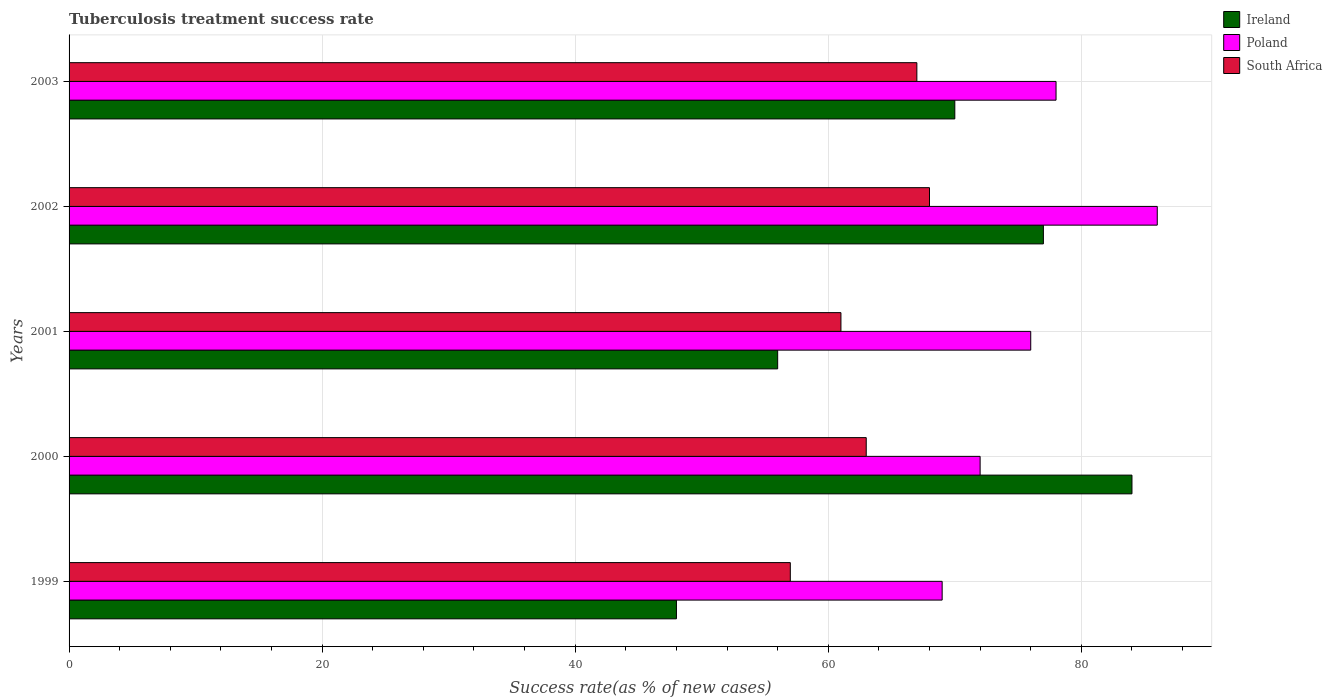How many groups of bars are there?
Keep it short and to the point. 5. Are the number of bars on each tick of the Y-axis equal?
Provide a short and direct response. Yes. What is the label of the 4th group of bars from the top?
Your response must be concise. 2000. In how many cases, is the number of bars for a given year not equal to the number of legend labels?
Ensure brevity in your answer.  0. What is the tuberculosis treatment success rate in Poland in 2001?
Your response must be concise. 76. Across all years, what is the maximum tuberculosis treatment success rate in South Africa?
Provide a succinct answer. 68. Across all years, what is the minimum tuberculosis treatment success rate in Ireland?
Provide a short and direct response. 48. In which year was the tuberculosis treatment success rate in South Africa maximum?
Your response must be concise. 2002. In which year was the tuberculosis treatment success rate in South Africa minimum?
Keep it short and to the point. 1999. What is the total tuberculosis treatment success rate in South Africa in the graph?
Ensure brevity in your answer.  316. What is the difference between the tuberculosis treatment success rate in Ireland in 2002 and that in 2003?
Offer a very short reply. 7. What is the difference between the tuberculosis treatment success rate in Ireland in 2000 and the tuberculosis treatment success rate in South Africa in 1999?
Your answer should be compact. 27. What is the average tuberculosis treatment success rate in Poland per year?
Provide a short and direct response. 76.2. What is the ratio of the tuberculosis treatment success rate in Ireland in 2001 to that in 2002?
Keep it short and to the point. 0.73. Is the tuberculosis treatment success rate in South Africa in 2000 less than that in 2002?
Give a very brief answer. Yes. Is the difference between the tuberculosis treatment success rate in Poland in 2002 and 2003 greater than the difference between the tuberculosis treatment success rate in Ireland in 2002 and 2003?
Offer a terse response. Yes. What is the difference between the highest and the second highest tuberculosis treatment success rate in Ireland?
Make the answer very short. 7. What is the difference between the highest and the lowest tuberculosis treatment success rate in South Africa?
Your answer should be compact. 11. In how many years, is the tuberculosis treatment success rate in Poland greater than the average tuberculosis treatment success rate in Poland taken over all years?
Your answer should be compact. 2. What does the 3rd bar from the top in 2003 represents?
Provide a succinct answer. Ireland. What does the 2nd bar from the bottom in 1999 represents?
Provide a short and direct response. Poland. Is it the case that in every year, the sum of the tuberculosis treatment success rate in Ireland and tuberculosis treatment success rate in Poland is greater than the tuberculosis treatment success rate in South Africa?
Offer a very short reply. Yes. How many years are there in the graph?
Offer a very short reply. 5. What is the difference between two consecutive major ticks on the X-axis?
Give a very brief answer. 20. Does the graph contain any zero values?
Your answer should be compact. No. Does the graph contain grids?
Make the answer very short. Yes. Where does the legend appear in the graph?
Keep it short and to the point. Top right. How many legend labels are there?
Provide a succinct answer. 3. How are the legend labels stacked?
Keep it short and to the point. Vertical. What is the title of the graph?
Your answer should be compact. Tuberculosis treatment success rate. Does "Angola" appear as one of the legend labels in the graph?
Make the answer very short. No. What is the label or title of the X-axis?
Ensure brevity in your answer.  Success rate(as % of new cases). What is the label or title of the Y-axis?
Keep it short and to the point. Years. What is the Success rate(as % of new cases) of Ireland in 2000?
Your answer should be compact. 84. What is the Success rate(as % of new cases) in Poland in 2000?
Your answer should be very brief. 72. What is the Success rate(as % of new cases) of Ireland in 2001?
Provide a short and direct response. 56. What is the Success rate(as % of new cases) of South Africa in 2001?
Your answer should be compact. 61. What is the Success rate(as % of new cases) in Poland in 2002?
Provide a succinct answer. 86. What is the Success rate(as % of new cases) in South Africa in 2002?
Your response must be concise. 68. What is the Success rate(as % of new cases) in South Africa in 2003?
Your answer should be compact. 67. Across all years, what is the maximum Success rate(as % of new cases) of Poland?
Ensure brevity in your answer.  86. Across all years, what is the minimum Success rate(as % of new cases) in South Africa?
Ensure brevity in your answer.  57. What is the total Success rate(as % of new cases) of Ireland in the graph?
Provide a short and direct response. 335. What is the total Success rate(as % of new cases) in Poland in the graph?
Provide a succinct answer. 381. What is the total Success rate(as % of new cases) in South Africa in the graph?
Provide a short and direct response. 316. What is the difference between the Success rate(as % of new cases) of Ireland in 1999 and that in 2000?
Give a very brief answer. -36. What is the difference between the Success rate(as % of new cases) in Poland in 1999 and that in 2001?
Provide a short and direct response. -7. What is the difference between the Success rate(as % of new cases) of Ireland in 1999 and that in 2002?
Keep it short and to the point. -29. What is the difference between the Success rate(as % of new cases) in Poland in 1999 and that in 2002?
Your response must be concise. -17. What is the difference between the Success rate(as % of new cases) of Poland in 1999 and that in 2003?
Make the answer very short. -9. What is the difference between the Success rate(as % of new cases) of South Africa in 1999 and that in 2003?
Your response must be concise. -10. What is the difference between the Success rate(as % of new cases) in Ireland in 2000 and that in 2001?
Your answer should be compact. 28. What is the difference between the Success rate(as % of new cases) in Poland in 2000 and that in 2001?
Offer a terse response. -4. What is the difference between the Success rate(as % of new cases) of South Africa in 2000 and that in 2001?
Ensure brevity in your answer.  2. What is the difference between the Success rate(as % of new cases) in Poland in 2000 and that in 2002?
Provide a succinct answer. -14. What is the difference between the Success rate(as % of new cases) in South Africa in 2000 and that in 2002?
Offer a very short reply. -5. What is the difference between the Success rate(as % of new cases) in Ireland in 2001 and that in 2002?
Keep it short and to the point. -21. What is the difference between the Success rate(as % of new cases) in South Africa in 2001 and that in 2002?
Provide a succinct answer. -7. What is the difference between the Success rate(as % of new cases) of Ireland in 2001 and that in 2003?
Offer a terse response. -14. What is the difference between the Success rate(as % of new cases) of Poland in 2002 and that in 2003?
Make the answer very short. 8. What is the difference between the Success rate(as % of new cases) of South Africa in 2002 and that in 2003?
Ensure brevity in your answer.  1. What is the difference between the Success rate(as % of new cases) of Poland in 1999 and the Success rate(as % of new cases) of South Africa in 2000?
Your answer should be compact. 6. What is the difference between the Success rate(as % of new cases) of Ireland in 1999 and the Success rate(as % of new cases) of Poland in 2002?
Provide a short and direct response. -38. What is the difference between the Success rate(as % of new cases) of Ireland in 1999 and the Success rate(as % of new cases) of South Africa in 2002?
Offer a terse response. -20. What is the difference between the Success rate(as % of new cases) of Ireland in 1999 and the Success rate(as % of new cases) of Poland in 2003?
Your answer should be compact. -30. What is the difference between the Success rate(as % of new cases) of Ireland in 2000 and the Success rate(as % of new cases) of Poland in 2001?
Give a very brief answer. 8. What is the difference between the Success rate(as % of new cases) in Ireland in 2000 and the Success rate(as % of new cases) in South Africa in 2001?
Offer a terse response. 23. What is the difference between the Success rate(as % of new cases) of Ireland in 2000 and the Success rate(as % of new cases) of Poland in 2002?
Your response must be concise. -2. What is the difference between the Success rate(as % of new cases) of Ireland in 2000 and the Success rate(as % of new cases) of South Africa in 2002?
Keep it short and to the point. 16. What is the difference between the Success rate(as % of new cases) in Ireland in 2000 and the Success rate(as % of new cases) in Poland in 2003?
Provide a succinct answer. 6. What is the difference between the Success rate(as % of new cases) in Ireland in 2001 and the Success rate(as % of new cases) in South Africa in 2002?
Your response must be concise. -12. What is the difference between the Success rate(as % of new cases) in Poland in 2001 and the Success rate(as % of new cases) in South Africa in 2002?
Your response must be concise. 8. What is the difference between the Success rate(as % of new cases) of Ireland in 2001 and the Success rate(as % of new cases) of Poland in 2003?
Your answer should be very brief. -22. What is the difference between the Success rate(as % of new cases) in Ireland in 2002 and the Success rate(as % of new cases) in Poland in 2003?
Your response must be concise. -1. What is the difference between the Success rate(as % of new cases) in Ireland in 2002 and the Success rate(as % of new cases) in South Africa in 2003?
Your answer should be compact. 10. What is the average Success rate(as % of new cases) of Ireland per year?
Ensure brevity in your answer.  67. What is the average Success rate(as % of new cases) of Poland per year?
Your response must be concise. 76.2. What is the average Success rate(as % of new cases) in South Africa per year?
Offer a very short reply. 63.2. In the year 2001, what is the difference between the Success rate(as % of new cases) of Ireland and Success rate(as % of new cases) of South Africa?
Your response must be concise. -5. What is the ratio of the Success rate(as % of new cases) of South Africa in 1999 to that in 2000?
Keep it short and to the point. 0.9. What is the ratio of the Success rate(as % of new cases) of Poland in 1999 to that in 2001?
Give a very brief answer. 0.91. What is the ratio of the Success rate(as % of new cases) in South Africa in 1999 to that in 2001?
Provide a succinct answer. 0.93. What is the ratio of the Success rate(as % of new cases) of Ireland in 1999 to that in 2002?
Your response must be concise. 0.62. What is the ratio of the Success rate(as % of new cases) in Poland in 1999 to that in 2002?
Provide a succinct answer. 0.8. What is the ratio of the Success rate(as % of new cases) in South Africa in 1999 to that in 2002?
Provide a short and direct response. 0.84. What is the ratio of the Success rate(as % of new cases) in Ireland in 1999 to that in 2003?
Provide a succinct answer. 0.69. What is the ratio of the Success rate(as % of new cases) in Poland in 1999 to that in 2003?
Keep it short and to the point. 0.88. What is the ratio of the Success rate(as % of new cases) of South Africa in 1999 to that in 2003?
Ensure brevity in your answer.  0.85. What is the ratio of the Success rate(as % of new cases) in Ireland in 2000 to that in 2001?
Provide a succinct answer. 1.5. What is the ratio of the Success rate(as % of new cases) of Poland in 2000 to that in 2001?
Make the answer very short. 0.95. What is the ratio of the Success rate(as % of new cases) in South Africa in 2000 to that in 2001?
Give a very brief answer. 1.03. What is the ratio of the Success rate(as % of new cases) in Ireland in 2000 to that in 2002?
Provide a succinct answer. 1.09. What is the ratio of the Success rate(as % of new cases) of Poland in 2000 to that in 2002?
Offer a very short reply. 0.84. What is the ratio of the Success rate(as % of new cases) of South Africa in 2000 to that in 2002?
Provide a short and direct response. 0.93. What is the ratio of the Success rate(as % of new cases) in Ireland in 2000 to that in 2003?
Keep it short and to the point. 1.2. What is the ratio of the Success rate(as % of new cases) of Poland in 2000 to that in 2003?
Give a very brief answer. 0.92. What is the ratio of the Success rate(as % of new cases) of South Africa in 2000 to that in 2003?
Provide a succinct answer. 0.94. What is the ratio of the Success rate(as % of new cases) of Ireland in 2001 to that in 2002?
Offer a terse response. 0.73. What is the ratio of the Success rate(as % of new cases) of Poland in 2001 to that in 2002?
Your answer should be very brief. 0.88. What is the ratio of the Success rate(as % of new cases) of South Africa in 2001 to that in 2002?
Your answer should be compact. 0.9. What is the ratio of the Success rate(as % of new cases) in Ireland in 2001 to that in 2003?
Make the answer very short. 0.8. What is the ratio of the Success rate(as % of new cases) in Poland in 2001 to that in 2003?
Provide a succinct answer. 0.97. What is the ratio of the Success rate(as % of new cases) of South Africa in 2001 to that in 2003?
Your answer should be compact. 0.91. What is the ratio of the Success rate(as % of new cases) in Ireland in 2002 to that in 2003?
Ensure brevity in your answer.  1.1. What is the ratio of the Success rate(as % of new cases) of Poland in 2002 to that in 2003?
Give a very brief answer. 1.1. What is the ratio of the Success rate(as % of new cases) of South Africa in 2002 to that in 2003?
Your response must be concise. 1.01. What is the difference between the highest and the second highest Success rate(as % of new cases) of Poland?
Your answer should be compact. 8. What is the difference between the highest and the second highest Success rate(as % of new cases) of South Africa?
Ensure brevity in your answer.  1. 